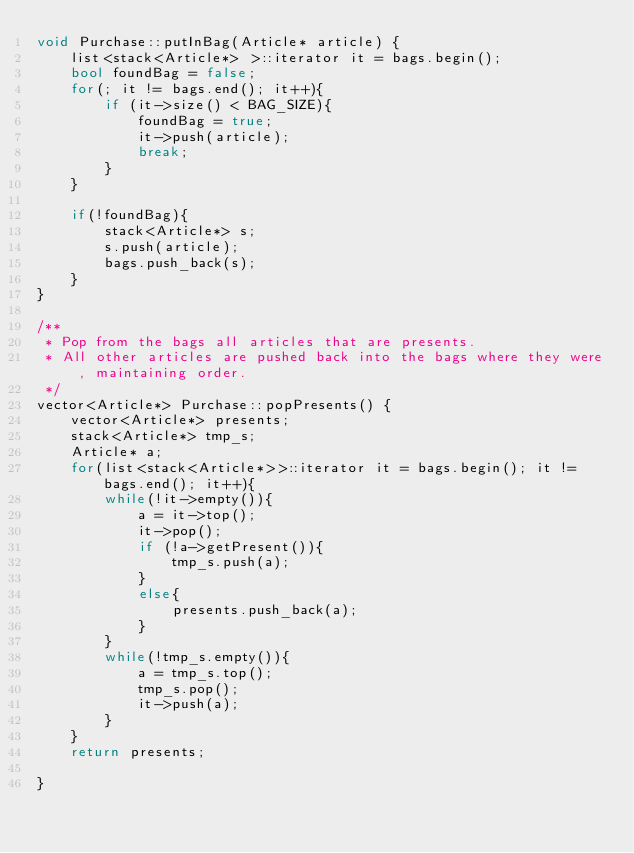<code> <loc_0><loc_0><loc_500><loc_500><_C++_>void Purchase::putInBag(Article* article) {
	list<stack<Article*> >::iterator it = bags.begin();
	bool foundBag = false;
	for(; it != bags.end(); it++){
		if (it->size() < BAG_SIZE){
			foundBag = true;
			it->push(article);
			break;
		}
	}

	if(!foundBag){
		stack<Article*> s;
		s.push(article);
		bags.push_back(s);
	}
}

/**
 * Pop from the bags all articles that are presents.
 * All other articles are pushed back into the bags where they were, maintaining order.
 */
vector<Article*> Purchase::popPresents() {
	vector<Article*> presents;
	stack<Article*> tmp_s;
	Article* a;
	for(list<stack<Article*>>::iterator it = bags.begin(); it != bags.end(); it++){
		while(!it->empty()){
			a = it->top();
			it->pop();
			if (!a->getPresent()){
				tmp_s.push(a);
			}
			else{
				presents.push_back(a);
			}
		}
		while(!tmp_s.empty()){
			a = tmp_s.top();
			tmp_s.pop();
			it->push(a);
		}
	}
	return presents;

}

</code> 